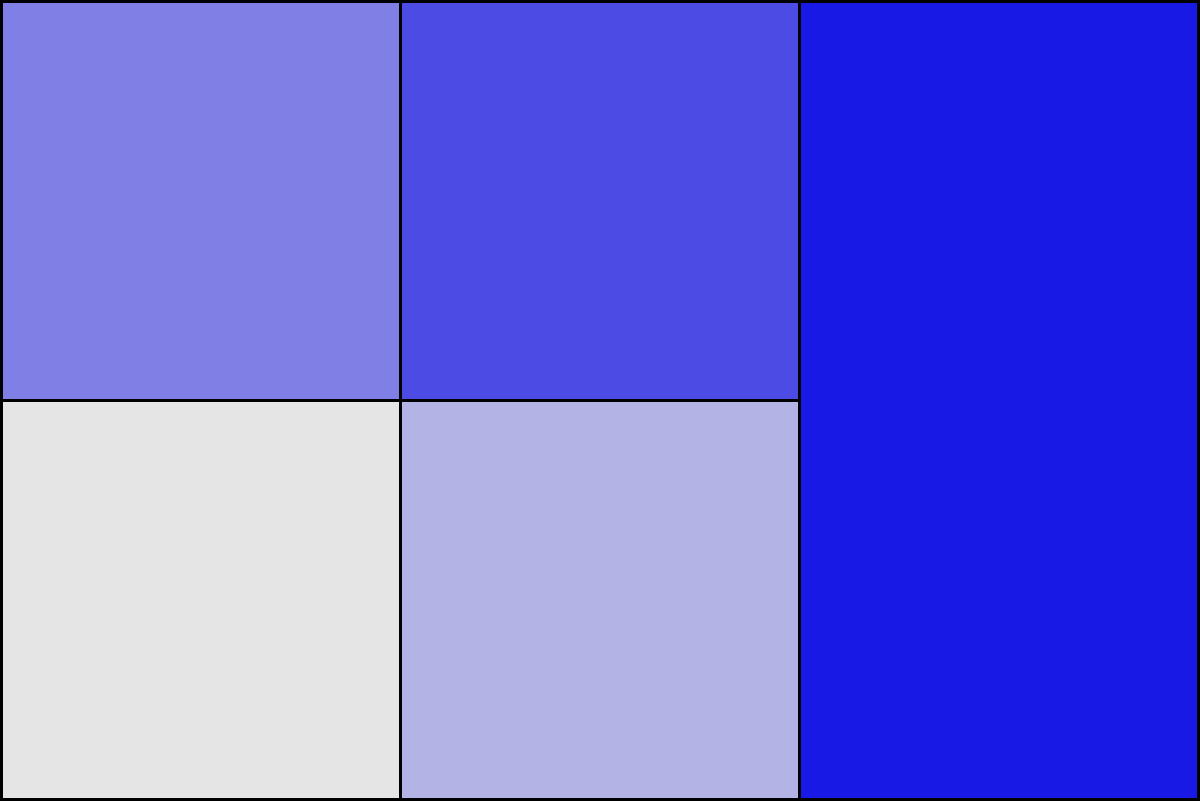As a local councilwoman advocating for your constituents, you're presented with the above choropleth map showing the distribution of public resources across five neighborhoods in your district. The numbers represent the percentage of allocated resources. Which neighborhood is most in need of your advocacy for increased resource allocation, and what is the total percentage difference between the highest and lowest resourced areas? To answer this question, we need to follow these steps:

1. Identify the neighborhood with the lowest resource allocation:
   - Examining the map, we see values of 10%, 30%, 50%, 70%, and 90%.
   - The lowest value is 10%, corresponding to the top-left neighborhood.

2. Identify the neighborhood with the highest resource allocation:
   - The highest value on the map is 90%, corresponding to the right-most neighborhood.

3. Calculate the difference between the highest and lowest resourced areas:
   - Highest allocation: 90%
   - Lowest allocation: 10%
   - Difference: $90\% - 10\% = 80\%$

4. Determine the neighborhood most in need of advocacy:
   - The neighborhood with the lowest resource allocation (10%) is most in need of advocacy for increased resources.

Therefore, as a councilwoman advocating for your constituents, you should focus on the top-left neighborhood (with 10% allocation), and the total percentage difference between the highest and lowest resourced areas is 80%.
Answer: Top-left neighborhood; 80% 